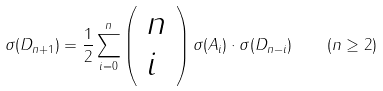<formula> <loc_0><loc_0><loc_500><loc_500>\sigma ( D _ { n + 1 } ) = \frac { 1 } { 2 } \sum _ { i = 0 } ^ { n } \left ( \begin{array} { l } n \\ i \end{array} \right ) \sigma ( A _ { i } ) \cdot \sigma ( D _ { n - i } ) \quad ( n \geq 2 )</formula> 